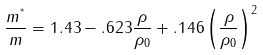Convert formula to latex. <formula><loc_0><loc_0><loc_500><loc_500>\frac { m ^ { ^ { * } } } { m } = 1 . 4 3 - . 6 2 3 \frac { \rho } { \rho _ { 0 } } + . 1 4 6 \left ( \frac { \rho } { \rho _ { 0 } } \right ) ^ { 2 }</formula> 